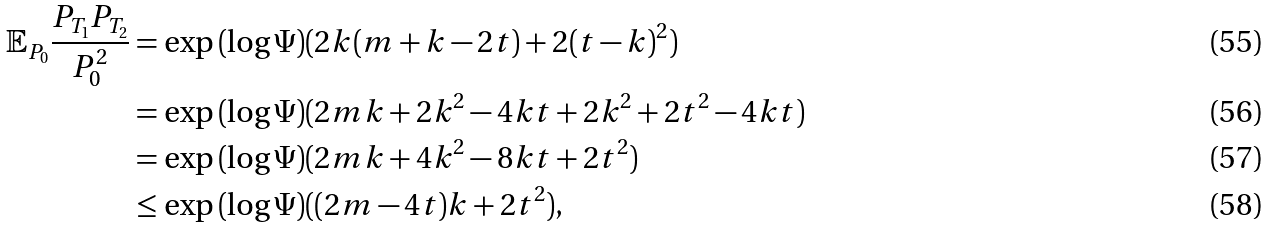Convert formula to latex. <formula><loc_0><loc_0><loc_500><loc_500>\mathbb { E } _ { P _ { 0 } } \frac { P _ { T _ { 1 } } P _ { T _ { 2 } } } { P _ { 0 } ^ { 2 } } & = \exp { ( \log \Psi ) ( 2 k ( m + k - 2 t ) + 2 ( t - k ) ^ { 2 } ) } \\ & = \exp { ( \log \Psi ) ( 2 m k + 2 k ^ { 2 } - 4 k t + 2 k ^ { 2 } + 2 t ^ { 2 } - 4 k t ) } \\ & = \exp { ( \log \Psi ) ( 2 m k + 4 k ^ { 2 } - 8 k t + 2 t ^ { 2 } ) } \\ & \leq \exp { ( \log \Psi ) ( ( 2 m - 4 t ) k + 2 t ^ { 2 } ) } ,</formula> 